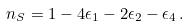<formula> <loc_0><loc_0><loc_500><loc_500>n _ { S } = 1 - 4 \epsilon _ { 1 } - 2 \epsilon _ { 2 } - \epsilon _ { 4 } \, .</formula> 